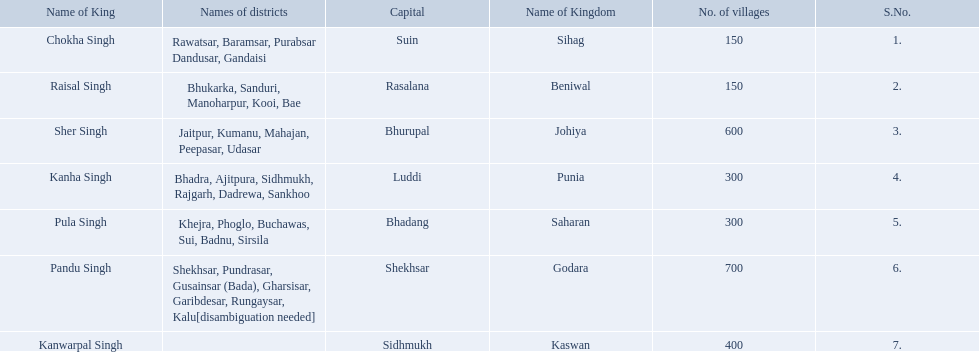What are all of the kingdoms? Sihag, Beniwal, Johiya, Punia, Saharan, Godara, Kaswan. How many villages do they contain? 150, 150, 600, 300, 300, 700, 400. How many are in godara? 700. Which kingdom comes next in highest amount of villages? Johiya. 